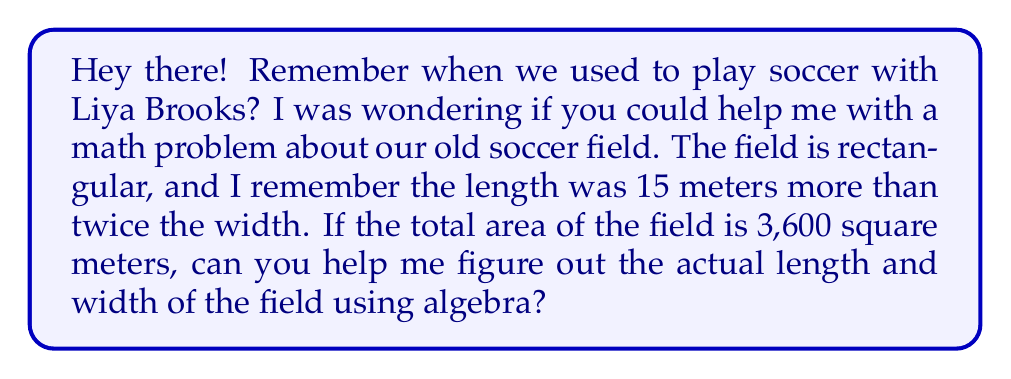Could you help me with this problem? Sure! Let's solve this step-by-step using algebra:

1) Let's define our variables:
   Let $w$ = width of the field
   Let $l$ = length of the field

2) We're told that the length is 15 meters more than twice the width:
   $l = 2w + 15$

3) We know that the area of a rectangle is length times width:
   $Area = l \times w$

4) We're given that the area is 3,600 square meters:
   $3600 = l \times w$

5) Let's substitute the expression for $l$ from step 2 into this equation:
   $3600 = (2w + 15) \times w$

6) Expand this:
   $3600 = 2w^2 + 15w$

7) Rearrange to standard form:
   $2w^2 + 15w - 3600 = 0$

8) This is a quadratic equation. We can solve it using the quadratic formula:
   $w = \frac{-b \pm \sqrt{b^2 - 4ac}}{2a}$

   Where $a = 2$, $b = 15$, and $c = -3600$

9) Substituting these values:
   $w = \frac{-15 \pm \sqrt{15^2 - 4(2)(-3600)}}{2(2)}$
   $= \frac{-15 \pm \sqrt{225 + 28800}}{4}$
   $= \frac{-15 \pm \sqrt{29025}}{4}$
   $= \frac{-15 \pm 170.37}{4}$

10) This gives us two solutions:
    $w = \frac{-15 + 170.37}{4} = 38.84$ or $w = \frac{-15 - 170.37}{4} = -46.34$

11) Since width can't be negative, we take the positive solution:
    $w = 38.84$ meters

12) To find the length, we use the equation from step 2:
    $l = 2(38.84) + 15 = 92.68$ meters

Therefore, the width of the field is 38.84 meters and the length is 92.68 meters.
Answer: The width of the soccer field is 38.84 meters and the length is 92.68 meters. 